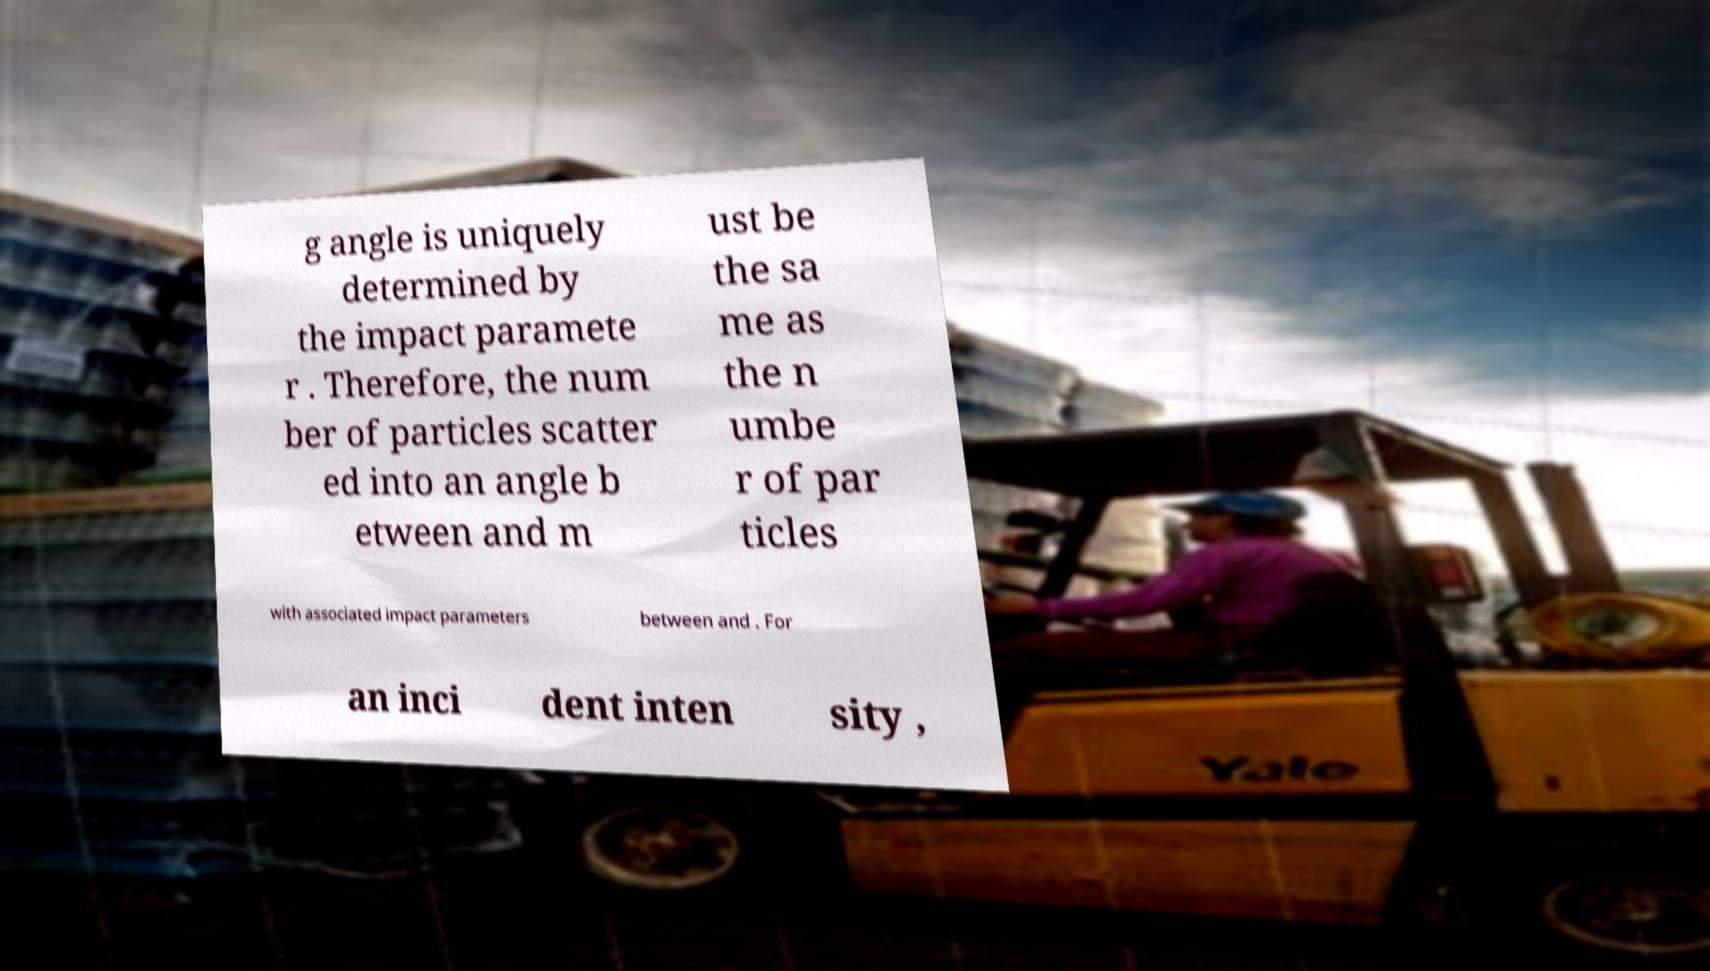I need the written content from this picture converted into text. Can you do that? g angle is uniquely determined by the impact paramete r . Therefore, the num ber of particles scatter ed into an angle b etween and m ust be the sa me as the n umbe r of par ticles with associated impact parameters between and . For an inci dent inten sity , 